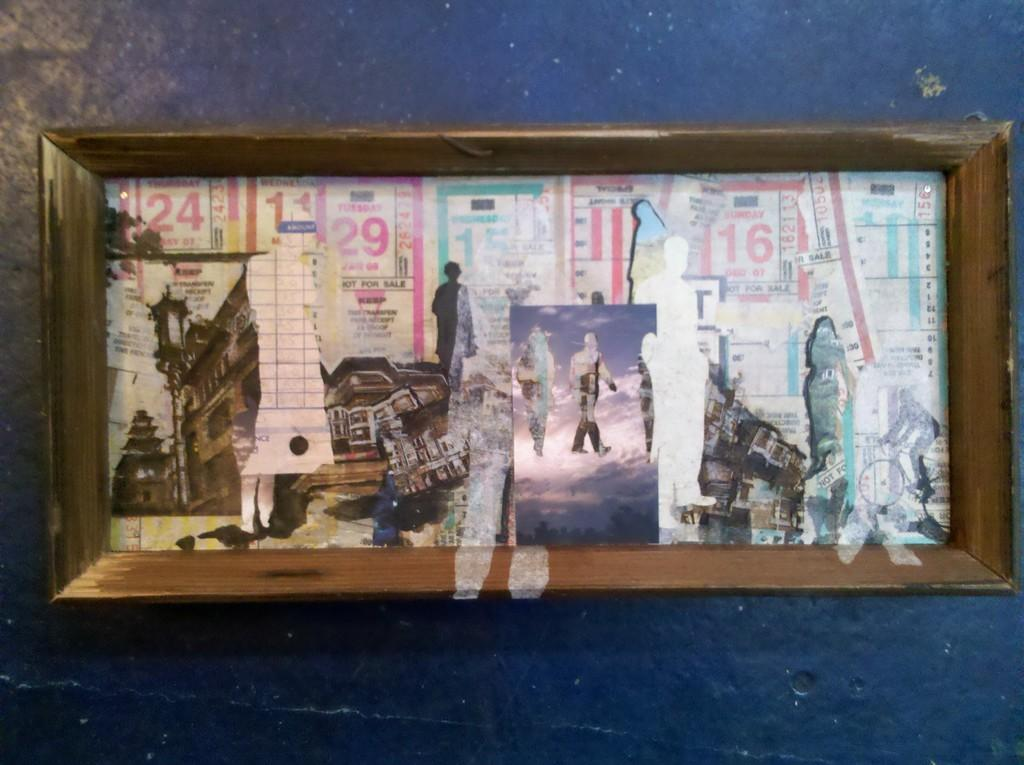What is the main object in the image? There is a wooden box in the image. What is located at the bottom of the wooden box? There are posters at the bottom of the box. Where is the wooden box situated? The wooden box is on a platform. What type of news can be seen on the ghost in the image? There is no ghost present in the image, and therefore no news can be seen on it. 